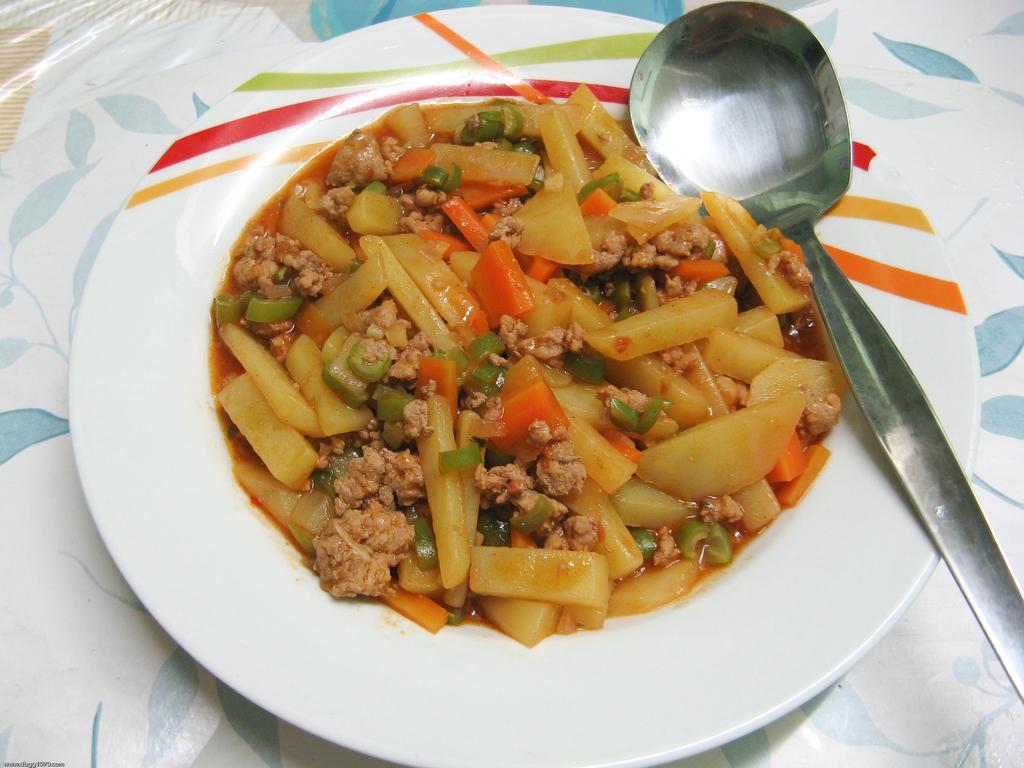Describe this image in one or two sentences. In this picture, we see a plate containing food and spoon are placed on the table, which is covered with white color cloth. 